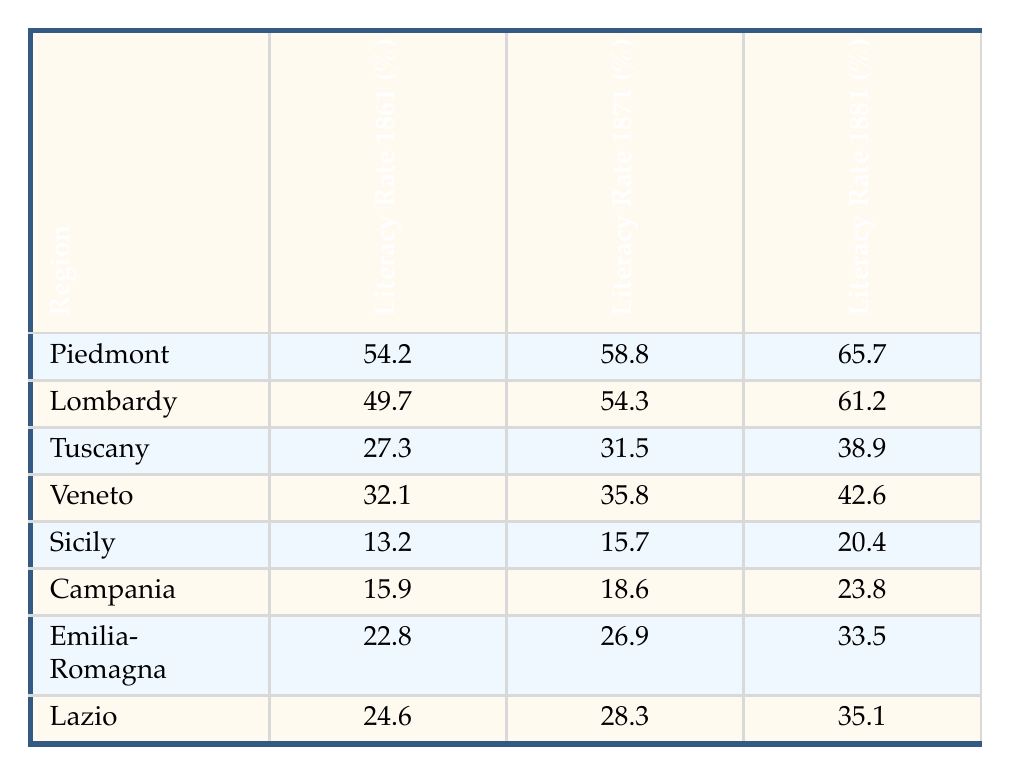What was the literacy rate in Piedmont in 1861? The table shows that the literacy rate in Piedmont in 1861 was 54.2%.
Answer: 54.2% Which region had the highest literacy rate in 1881? According to the table, Piedmont had the highest literacy rate in 1881 at 65.7%.
Answer: Piedmont What was the increase in literacy rate for Tuscany from 1861 to 1881? The literacy rate for Tuscany in 1861 was 27.3%, and in 1881 it was 38.9%. To find the increase, subtract the two values: 38.9 - 27.3 = 11.6.
Answer: 11.6% Did Sicily have a higher literacy rate than Campania in 1871? The table indicates that Sicily had a literacy rate of 15.7% in 1871, while Campania had a rate of 18.6%. Thus, Sicily did not have a higher literacy rate than Campania.
Answer: No What is the average literacy rate in 1871 across all the regions listed? The literacy rates in 1871 for the regions are: Piedmont (58.8), Lombardy (54.3), Tuscany (31.5), Veneto (35.8), Sicily (15.7), Campania (18.6), Emilia-Romagna (26.9), and Lazio (28.3). To calculate the average: (58.8 + 54.3 + 31.5 + 35.8 + 15.7 + 18.6 + 26.9 + 28.3) / 8 = 37.8.
Answer: 37.8 Was the literacy rate in Lazio in 1881 below 40%? In 1881, Lazio's literacy rate was 35.1%, which is below 40%. Thus, the statement is true.
Answer: Yes What was the difference in literacy rates between Lombardy and Emilia-Romagna in 1861? Lombardy had a literacy rate of 49.7% and Emilia-Romagna had 22.8% in 1861. The difference is calculated as 49.7 - 22.8 = 26.9.
Answer: 26.9 Which region showed the least improvement in literacy rate from 1861 to 1881? By examining the improvements for each region: Piedmont (11.5), Lombardy (11.5), Tuscany (11.6), Veneto (10.5), Sicily (7.2), Campania (7.9), Emilia-Romagna (10.7), Lazio (10.5), it is evident that Sicily showed the least improvement.
Answer: Sicily 